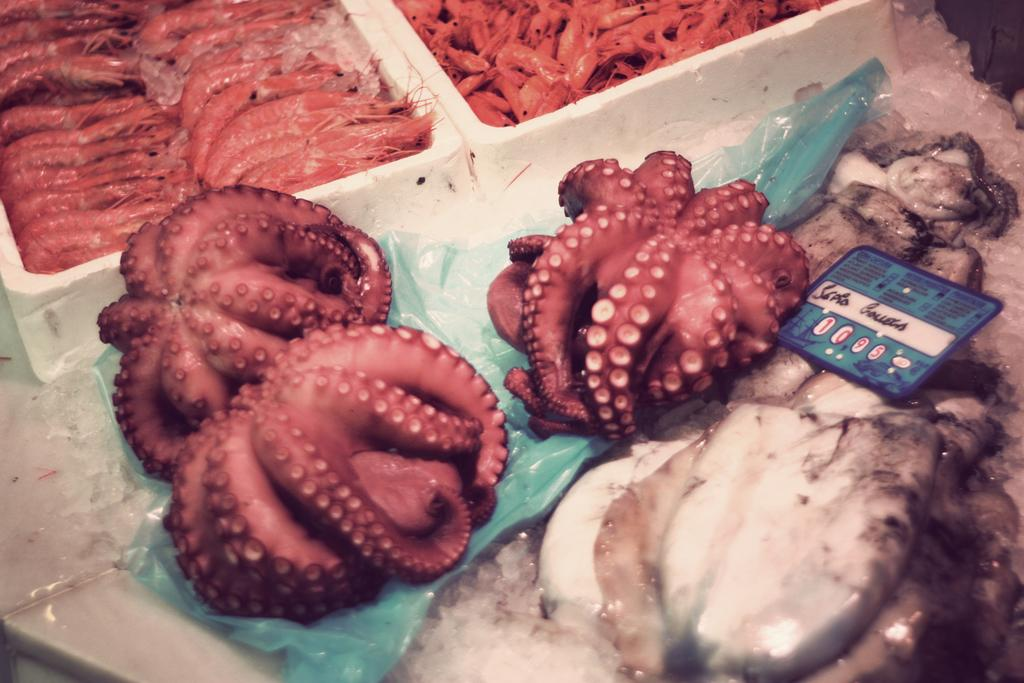What type of animals can be seen on the green cover in the image? There are small fishes on a green cover in the image. Can you describe the fishes in the image? Yes, there are fishes visible in the image. What are the white boxes in the image containing? The white boxes in the image contain prawns or some kind of dishes. What type of caption is written on the green cover in the image? There is no caption written on the green cover in the image; it only has small fishes. Can you see a parent with the fishes in the image? There is no parent present in the image; it only features fishes and white boxes containing prawns or dishes. 